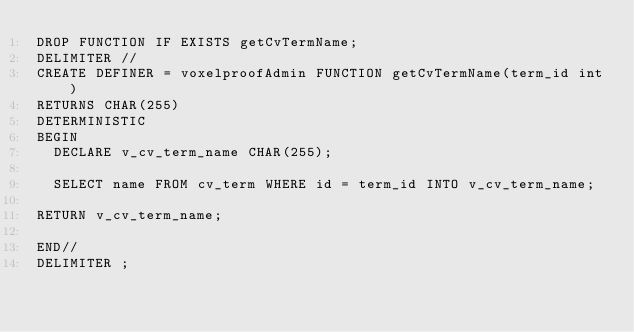<code> <loc_0><loc_0><loc_500><loc_500><_SQL_>DROP FUNCTION IF EXISTS getCvTermName;
DELIMITER //
CREATE DEFINER = voxelproofAdmin FUNCTION getCvTermName(term_id int)
RETURNS CHAR(255)
DETERMINISTIC
BEGIN
  DECLARE v_cv_term_name CHAR(255);

  SELECT name FROM cv_term WHERE id = term_id INTO v_cv_term_name;

RETURN v_cv_term_name;

END//
DELIMITER ;
</code> 